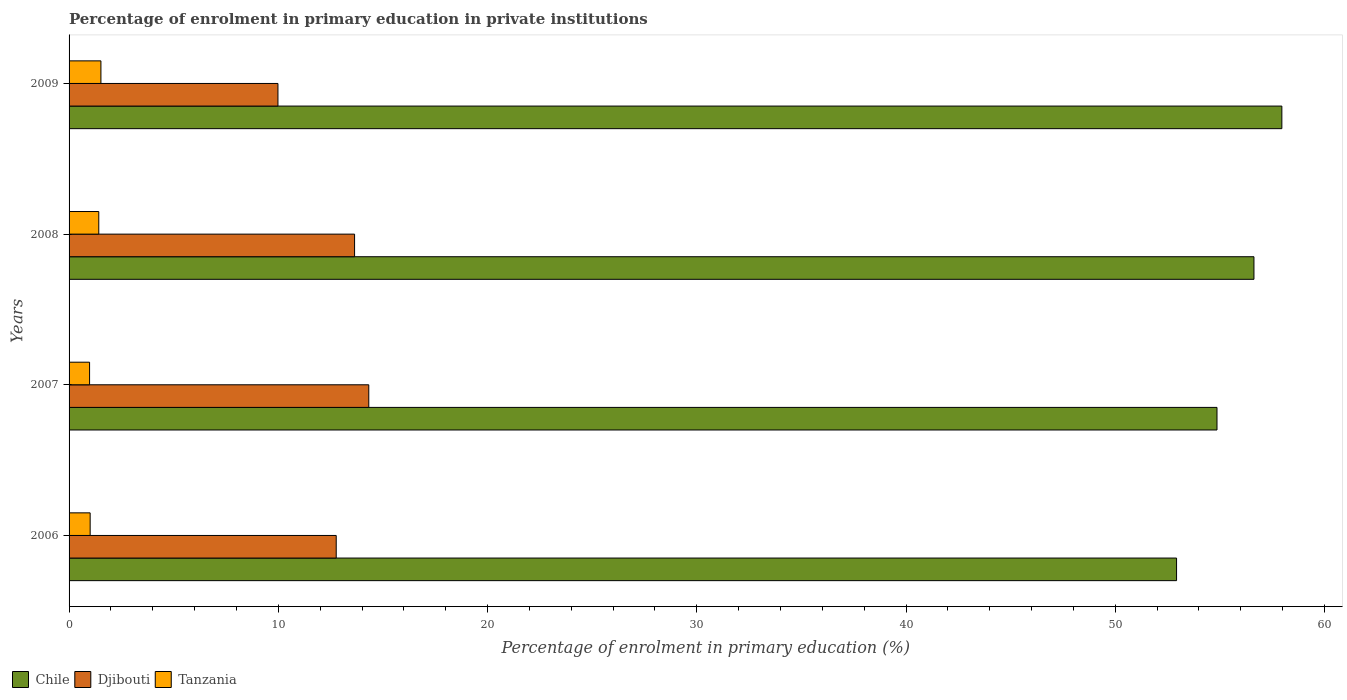Are the number of bars on each tick of the Y-axis equal?
Your response must be concise. Yes. What is the label of the 1st group of bars from the top?
Offer a terse response. 2009. In how many cases, is the number of bars for a given year not equal to the number of legend labels?
Offer a very short reply. 0. What is the percentage of enrolment in primary education in Djibouti in 2009?
Keep it short and to the point. 9.98. Across all years, what is the maximum percentage of enrolment in primary education in Chile?
Your answer should be compact. 57.96. Across all years, what is the minimum percentage of enrolment in primary education in Tanzania?
Offer a very short reply. 0.98. In which year was the percentage of enrolment in primary education in Chile maximum?
Offer a terse response. 2009. What is the total percentage of enrolment in primary education in Djibouti in the graph?
Provide a succinct answer. 50.72. What is the difference between the percentage of enrolment in primary education in Chile in 2006 and that in 2009?
Provide a short and direct response. -5.03. What is the difference between the percentage of enrolment in primary education in Tanzania in 2009 and the percentage of enrolment in primary education in Chile in 2008?
Your response must be concise. -55.11. What is the average percentage of enrolment in primary education in Chile per year?
Provide a short and direct response. 55.6. In the year 2007, what is the difference between the percentage of enrolment in primary education in Djibouti and percentage of enrolment in primary education in Chile?
Keep it short and to the point. -40.54. In how many years, is the percentage of enrolment in primary education in Chile greater than 22 %?
Your answer should be very brief. 4. What is the ratio of the percentage of enrolment in primary education in Chile in 2007 to that in 2008?
Your answer should be compact. 0.97. What is the difference between the highest and the second highest percentage of enrolment in primary education in Djibouti?
Give a very brief answer. 0.68. What is the difference between the highest and the lowest percentage of enrolment in primary education in Djibouti?
Offer a terse response. 4.34. What does the 1st bar from the top in 2009 represents?
Ensure brevity in your answer.  Tanzania. What does the 3rd bar from the bottom in 2009 represents?
Your answer should be compact. Tanzania. What is the difference between two consecutive major ticks on the X-axis?
Ensure brevity in your answer.  10. Does the graph contain any zero values?
Provide a succinct answer. No. Where does the legend appear in the graph?
Keep it short and to the point. Bottom left. What is the title of the graph?
Offer a very short reply. Percentage of enrolment in primary education in private institutions. Does "Micronesia" appear as one of the legend labels in the graph?
Provide a short and direct response. No. What is the label or title of the X-axis?
Provide a short and direct response. Percentage of enrolment in primary education (%). What is the label or title of the Y-axis?
Offer a very short reply. Years. What is the Percentage of enrolment in primary education (%) of Chile in 2006?
Your answer should be compact. 52.93. What is the Percentage of enrolment in primary education (%) in Djibouti in 2006?
Your answer should be compact. 12.77. What is the Percentage of enrolment in primary education (%) of Tanzania in 2006?
Provide a short and direct response. 1.01. What is the Percentage of enrolment in primary education (%) in Chile in 2007?
Offer a terse response. 54.86. What is the Percentage of enrolment in primary education (%) in Djibouti in 2007?
Give a very brief answer. 14.32. What is the Percentage of enrolment in primary education (%) in Tanzania in 2007?
Make the answer very short. 0.98. What is the Percentage of enrolment in primary education (%) of Chile in 2008?
Your answer should be compact. 56.63. What is the Percentage of enrolment in primary education (%) of Djibouti in 2008?
Your answer should be very brief. 13.64. What is the Percentage of enrolment in primary education (%) in Tanzania in 2008?
Your response must be concise. 1.42. What is the Percentage of enrolment in primary education (%) in Chile in 2009?
Give a very brief answer. 57.96. What is the Percentage of enrolment in primary education (%) of Djibouti in 2009?
Ensure brevity in your answer.  9.98. What is the Percentage of enrolment in primary education (%) in Tanzania in 2009?
Offer a terse response. 1.52. Across all years, what is the maximum Percentage of enrolment in primary education (%) in Chile?
Offer a terse response. 57.96. Across all years, what is the maximum Percentage of enrolment in primary education (%) of Djibouti?
Offer a terse response. 14.32. Across all years, what is the maximum Percentage of enrolment in primary education (%) of Tanzania?
Offer a very short reply. 1.52. Across all years, what is the minimum Percentage of enrolment in primary education (%) in Chile?
Keep it short and to the point. 52.93. Across all years, what is the minimum Percentage of enrolment in primary education (%) in Djibouti?
Your answer should be very brief. 9.98. Across all years, what is the minimum Percentage of enrolment in primary education (%) in Tanzania?
Your answer should be very brief. 0.98. What is the total Percentage of enrolment in primary education (%) of Chile in the graph?
Provide a succinct answer. 222.38. What is the total Percentage of enrolment in primary education (%) of Djibouti in the graph?
Keep it short and to the point. 50.72. What is the total Percentage of enrolment in primary education (%) in Tanzania in the graph?
Provide a succinct answer. 4.93. What is the difference between the Percentage of enrolment in primary education (%) in Chile in 2006 and that in 2007?
Ensure brevity in your answer.  -1.93. What is the difference between the Percentage of enrolment in primary education (%) in Djibouti in 2006 and that in 2007?
Keep it short and to the point. -1.56. What is the difference between the Percentage of enrolment in primary education (%) in Tanzania in 2006 and that in 2007?
Your response must be concise. 0.03. What is the difference between the Percentage of enrolment in primary education (%) in Chile in 2006 and that in 2008?
Offer a very short reply. -3.7. What is the difference between the Percentage of enrolment in primary education (%) of Djibouti in 2006 and that in 2008?
Your answer should be compact. -0.88. What is the difference between the Percentage of enrolment in primary education (%) of Tanzania in 2006 and that in 2008?
Provide a short and direct response. -0.41. What is the difference between the Percentage of enrolment in primary education (%) in Chile in 2006 and that in 2009?
Make the answer very short. -5.03. What is the difference between the Percentage of enrolment in primary education (%) in Djibouti in 2006 and that in 2009?
Your answer should be compact. 2.79. What is the difference between the Percentage of enrolment in primary education (%) in Tanzania in 2006 and that in 2009?
Your answer should be compact. -0.51. What is the difference between the Percentage of enrolment in primary education (%) in Chile in 2007 and that in 2008?
Offer a terse response. -1.77. What is the difference between the Percentage of enrolment in primary education (%) in Djibouti in 2007 and that in 2008?
Make the answer very short. 0.68. What is the difference between the Percentage of enrolment in primary education (%) in Tanzania in 2007 and that in 2008?
Your answer should be very brief. -0.44. What is the difference between the Percentage of enrolment in primary education (%) of Chile in 2007 and that in 2009?
Your response must be concise. -3.1. What is the difference between the Percentage of enrolment in primary education (%) of Djibouti in 2007 and that in 2009?
Keep it short and to the point. 4.34. What is the difference between the Percentage of enrolment in primary education (%) of Tanzania in 2007 and that in 2009?
Your answer should be compact. -0.54. What is the difference between the Percentage of enrolment in primary education (%) of Chile in 2008 and that in 2009?
Make the answer very short. -1.33. What is the difference between the Percentage of enrolment in primary education (%) in Djibouti in 2008 and that in 2009?
Ensure brevity in your answer.  3.66. What is the difference between the Percentage of enrolment in primary education (%) of Tanzania in 2008 and that in 2009?
Provide a succinct answer. -0.1. What is the difference between the Percentage of enrolment in primary education (%) in Chile in 2006 and the Percentage of enrolment in primary education (%) in Djibouti in 2007?
Provide a succinct answer. 38.61. What is the difference between the Percentage of enrolment in primary education (%) of Chile in 2006 and the Percentage of enrolment in primary education (%) of Tanzania in 2007?
Offer a very short reply. 51.95. What is the difference between the Percentage of enrolment in primary education (%) in Djibouti in 2006 and the Percentage of enrolment in primary education (%) in Tanzania in 2007?
Your answer should be compact. 11.79. What is the difference between the Percentage of enrolment in primary education (%) of Chile in 2006 and the Percentage of enrolment in primary education (%) of Djibouti in 2008?
Offer a very short reply. 39.28. What is the difference between the Percentage of enrolment in primary education (%) of Chile in 2006 and the Percentage of enrolment in primary education (%) of Tanzania in 2008?
Ensure brevity in your answer.  51.51. What is the difference between the Percentage of enrolment in primary education (%) in Djibouti in 2006 and the Percentage of enrolment in primary education (%) in Tanzania in 2008?
Provide a short and direct response. 11.35. What is the difference between the Percentage of enrolment in primary education (%) in Chile in 2006 and the Percentage of enrolment in primary education (%) in Djibouti in 2009?
Your answer should be very brief. 42.95. What is the difference between the Percentage of enrolment in primary education (%) in Chile in 2006 and the Percentage of enrolment in primary education (%) in Tanzania in 2009?
Ensure brevity in your answer.  51.41. What is the difference between the Percentage of enrolment in primary education (%) in Djibouti in 2006 and the Percentage of enrolment in primary education (%) in Tanzania in 2009?
Offer a very short reply. 11.25. What is the difference between the Percentage of enrolment in primary education (%) of Chile in 2007 and the Percentage of enrolment in primary education (%) of Djibouti in 2008?
Your answer should be very brief. 41.22. What is the difference between the Percentage of enrolment in primary education (%) of Chile in 2007 and the Percentage of enrolment in primary education (%) of Tanzania in 2008?
Your response must be concise. 53.44. What is the difference between the Percentage of enrolment in primary education (%) of Djibouti in 2007 and the Percentage of enrolment in primary education (%) of Tanzania in 2008?
Provide a succinct answer. 12.9. What is the difference between the Percentage of enrolment in primary education (%) in Chile in 2007 and the Percentage of enrolment in primary education (%) in Djibouti in 2009?
Your response must be concise. 44.88. What is the difference between the Percentage of enrolment in primary education (%) in Chile in 2007 and the Percentage of enrolment in primary education (%) in Tanzania in 2009?
Ensure brevity in your answer.  53.34. What is the difference between the Percentage of enrolment in primary education (%) of Djibouti in 2007 and the Percentage of enrolment in primary education (%) of Tanzania in 2009?
Your answer should be very brief. 12.8. What is the difference between the Percentage of enrolment in primary education (%) in Chile in 2008 and the Percentage of enrolment in primary education (%) in Djibouti in 2009?
Provide a short and direct response. 46.65. What is the difference between the Percentage of enrolment in primary education (%) in Chile in 2008 and the Percentage of enrolment in primary education (%) in Tanzania in 2009?
Ensure brevity in your answer.  55.11. What is the difference between the Percentage of enrolment in primary education (%) in Djibouti in 2008 and the Percentage of enrolment in primary education (%) in Tanzania in 2009?
Ensure brevity in your answer.  12.12. What is the average Percentage of enrolment in primary education (%) of Chile per year?
Your answer should be compact. 55.6. What is the average Percentage of enrolment in primary education (%) of Djibouti per year?
Make the answer very short. 12.68. What is the average Percentage of enrolment in primary education (%) of Tanzania per year?
Give a very brief answer. 1.23. In the year 2006, what is the difference between the Percentage of enrolment in primary education (%) of Chile and Percentage of enrolment in primary education (%) of Djibouti?
Offer a terse response. 40.16. In the year 2006, what is the difference between the Percentage of enrolment in primary education (%) of Chile and Percentage of enrolment in primary education (%) of Tanzania?
Keep it short and to the point. 51.92. In the year 2006, what is the difference between the Percentage of enrolment in primary education (%) in Djibouti and Percentage of enrolment in primary education (%) in Tanzania?
Make the answer very short. 11.76. In the year 2007, what is the difference between the Percentage of enrolment in primary education (%) of Chile and Percentage of enrolment in primary education (%) of Djibouti?
Your answer should be compact. 40.54. In the year 2007, what is the difference between the Percentage of enrolment in primary education (%) in Chile and Percentage of enrolment in primary education (%) in Tanzania?
Ensure brevity in your answer.  53.88. In the year 2007, what is the difference between the Percentage of enrolment in primary education (%) in Djibouti and Percentage of enrolment in primary education (%) in Tanzania?
Provide a short and direct response. 13.34. In the year 2008, what is the difference between the Percentage of enrolment in primary education (%) in Chile and Percentage of enrolment in primary education (%) in Djibouti?
Offer a very short reply. 42.98. In the year 2008, what is the difference between the Percentage of enrolment in primary education (%) of Chile and Percentage of enrolment in primary education (%) of Tanzania?
Ensure brevity in your answer.  55.21. In the year 2008, what is the difference between the Percentage of enrolment in primary education (%) in Djibouti and Percentage of enrolment in primary education (%) in Tanzania?
Your response must be concise. 12.22. In the year 2009, what is the difference between the Percentage of enrolment in primary education (%) of Chile and Percentage of enrolment in primary education (%) of Djibouti?
Your answer should be very brief. 47.98. In the year 2009, what is the difference between the Percentage of enrolment in primary education (%) of Chile and Percentage of enrolment in primary education (%) of Tanzania?
Make the answer very short. 56.44. In the year 2009, what is the difference between the Percentage of enrolment in primary education (%) of Djibouti and Percentage of enrolment in primary education (%) of Tanzania?
Keep it short and to the point. 8.46. What is the ratio of the Percentage of enrolment in primary education (%) of Chile in 2006 to that in 2007?
Offer a terse response. 0.96. What is the ratio of the Percentage of enrolment in primary education (%) of Djibouti in 2006 to that in 2007?
Offer a terse response. 0.89. What is the ratio of the Percentage of enrolment in primary education (%) in Tanzania in 2006 to that in 2007?
Your response must be concise. 1.03. What is the ratio of the Percentage of enrolment in primary education (%) of Chile in 2006 to that in 2008?
Ensure brevity in your answer.  0.93. What is the ratio of the Percentage of enrolment in primary education (%) of Djibouti in 2006 to that in 2008?
Your answer should be compact. 0.94. What is the ratio of the Percentage of enrolment in primary education (%) in Tanzania in 2006 to that in 2008?
Make the answer very short. 0.71. What is the ratio of the Percentage of enrolment in primary education (%) of Chile in 2006 to that in 2009?
Make the answer very short. 0.91. What is the ratio of the Percentage of enrolment in primary education (%) of Djibouti in 2006 to that in 2009?
Your answer should be very brief. 1.28. What is the ratio of the Percentage of enrolment in primary education (%) of Tanzania in 2006 to that in 2009?
Offer a terse response. 0.66. What is the ratio of the Percentage of enrolment in primary education (%) in Chile in 2007 to that in 2008?
Keep it short and to the point. 0.97. What is the ratio of the Percentage of enrolment in primary education (%) in Djibouti in 2007 to that in 2008?
Offer a very short reply. 1.05. What is the ratio of the Percentage of enrolment in primary education (%) of Tanzania in 2007 to that in 2008?
Your answer should be compact. 0.69. What is the ratio of the Percentage of enrolment in primary education (%) of Chile in 2007 to that in 2009?
Your answer should be compact. 0.95. What is the ratio of the Percentage of enrolment in primary education (%) in Djibouti in 2007 to that in 2009?
Keep it short and to the point. 1.43. What is the ratio of the Percentage of enrolment in primary education (%) in Tanzania in 2007 to that in 2009?
Keep it short and to the point. 0.64. What is the ratio of the Percentage of enrolment in primary education (%) in Chile in 2008 to that in 2009?
Provide a short and direct response. 0.98. What is the ratio of the Percentage of enrolment in primary education (%) in Djibouti in 2008 to that in 2009?
Offer a terse response. 1.37. What is the ratio of the Percentage of enrolment in primary education (%) of Tanzania in 2008 to that in 2009?
Provide a succinct answer. 0.93. What is the difference between the highest and the second highest Percentage of enrolment in primary education (%) in Chile?
Ensure brevity in your answer.  1.33. What is the difference between the highest and the second highest Percentage of enrolment in primary education (%) of Djibouti?
Your answer should be very brief. 0.68. What is the difference between the highest and the second highest Percentage of enrolment in primary education (%) of Tanzania?
Make the answer very short. 0.1. What is the difference between the highest and the lowest Percentage of enrolment in primary education (%) in Chile?
Provide a short and direct response. 5.03. What is the difference between the highest and the lowest Percentage of enrolment in primary education (%) in Djibouti?
Provide a short and direct response. 4.34. What is the difference between the highest and the lowest Percentage of enrolment in primary education (%) in Tanzania?
Your response must be concise. 0.54. 